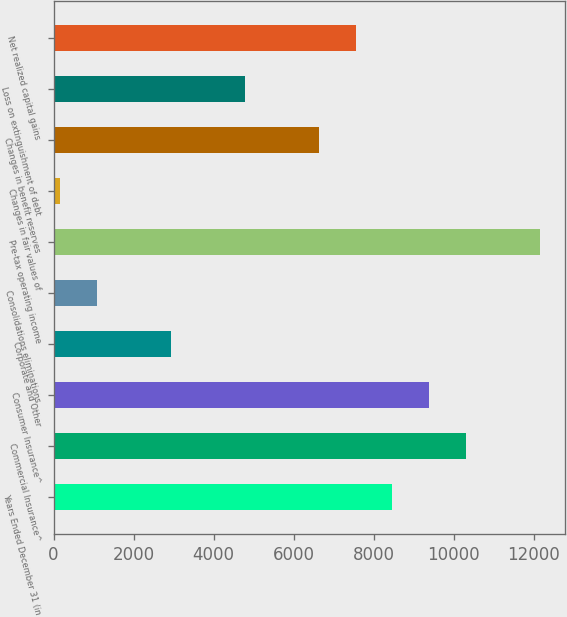Convert chart to OTSL. <chart><loc_0><loc_0><loc_500><loc_500><bar_chart><fcel>Years Ended December 31 (in<fcel>Commercial Insurance^<fcel>Consumer Insurance^<fcel>Corporate and Other<fcel>Consolidations eliminations<fcel>Pre-tax operating income<fcel>Changes in fair values of<fcel>Changes in benefit reserves<fcel>Loss on extinguishment of debt<fcel>Net realized capital gains<nl><fcel>8467.1<fcel>10312.9<fcel>9390<fcel>2929.7<fcel>1083.9<fcel>12158.7<fcel>161<fcel>6621.3<fcel>4775.5<fcel>7544.2<nl></chart> 